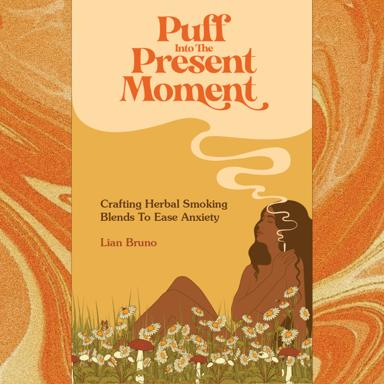What is the subject of the book or article? The book delves into the preparation of herbal smoking blends specially designed to alleviate anxiety. It emphasizes the use of natural, calming ingredients, contributing to a holistic approach towards managing stress and enhancing mental well-being. 